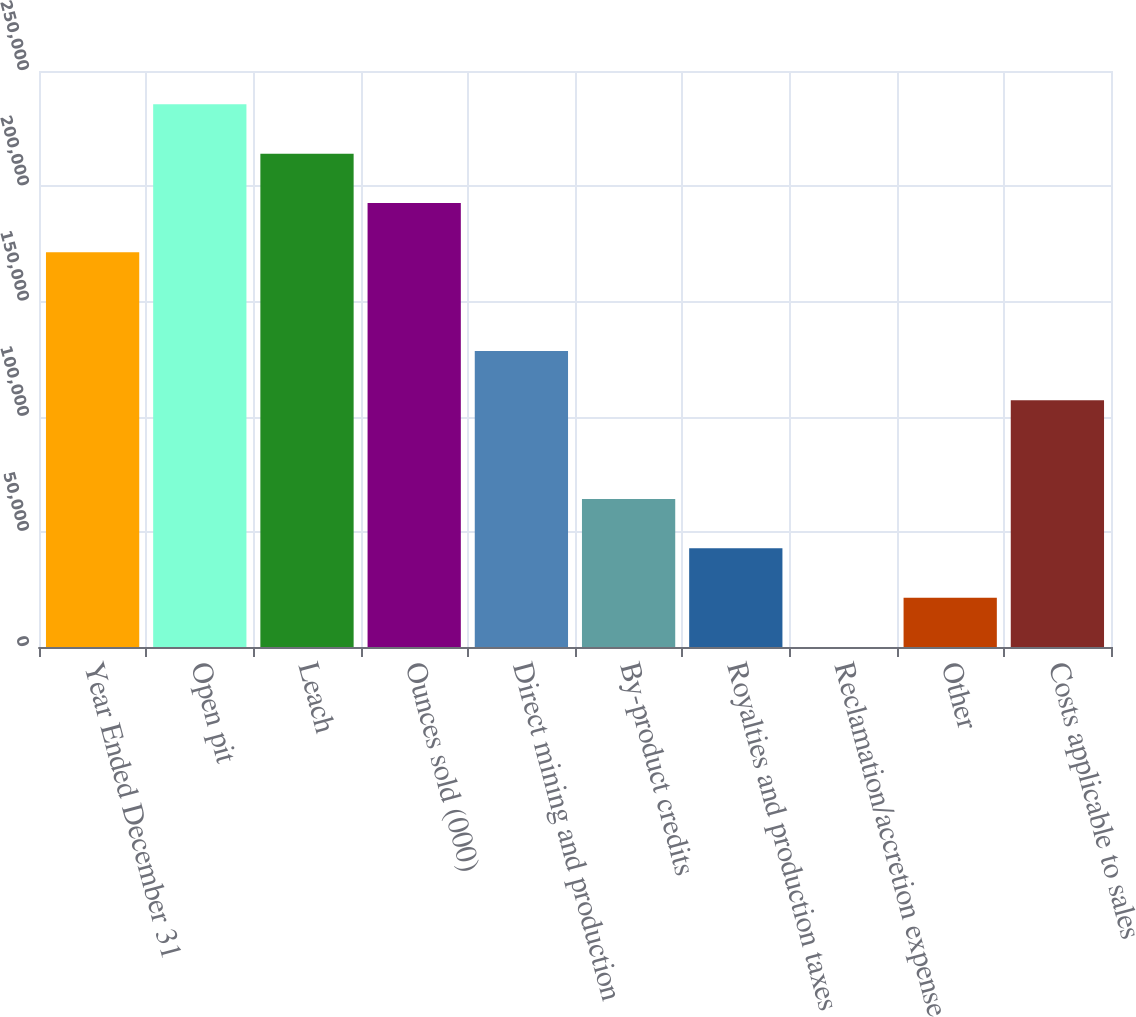Convert chart. <chart><loc_0><loc_0><loc_500><loc_500><bar_chart><fcel>Year Ended December 31<fcel>Open pit<fcel>Leach<fcel>Ounces sold (000)<fcel>Direct mining and production<fcel>By-product credits<fcel>Royalties and production taxes<fcel>Reclamation/accretion expense<fcel>Other<fcel>Costs applicable to sales<nl><fcel>171302<fcel>235540<fcel>214127<fcel>192714<fcel>128477<fcel>64239.5<fcel>42827<fcel>2<fcel>21414.5<fcel>107064<nl></chart> 